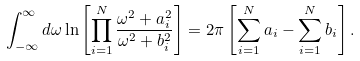Convert formula to latex. <formula><loc_0><loc_0><loc_500><loc_500>\int _ { - \infty } ^ { \infty } d \omega \ln \left [ \prod _ { i = 1 } ^ { N } \frac { \omega ^ { 2 } + a _ { i } ^ { 2 } } { \omega ^ { 2 } + b _ { i } ^ { 2 } } \right ] = 2 \pi \left [ \sum _ { i = 1 } ^ { N } a _ { i } - \sum _ { i = 1 } ^ { N } b _ { i } \right ] .</formula> 